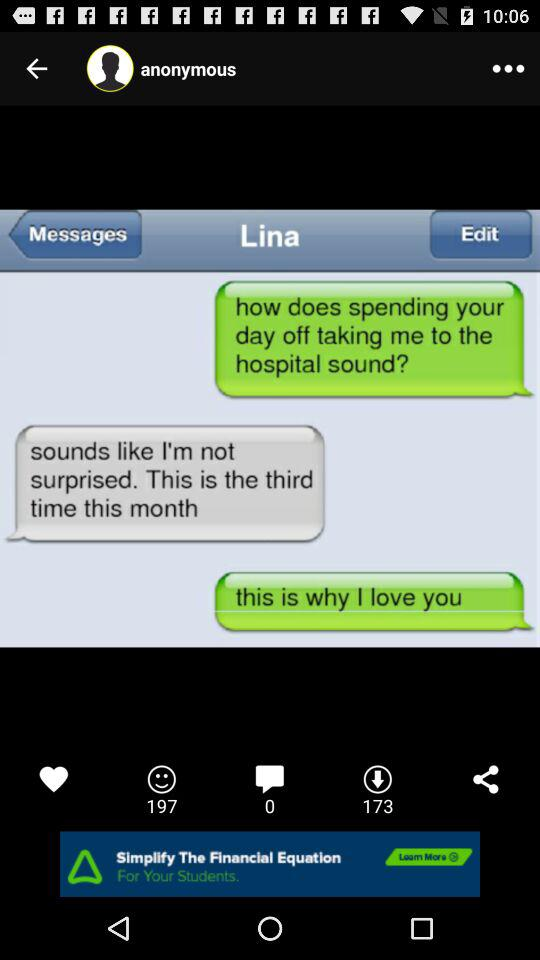How many messages are there? There are 0 messages. 